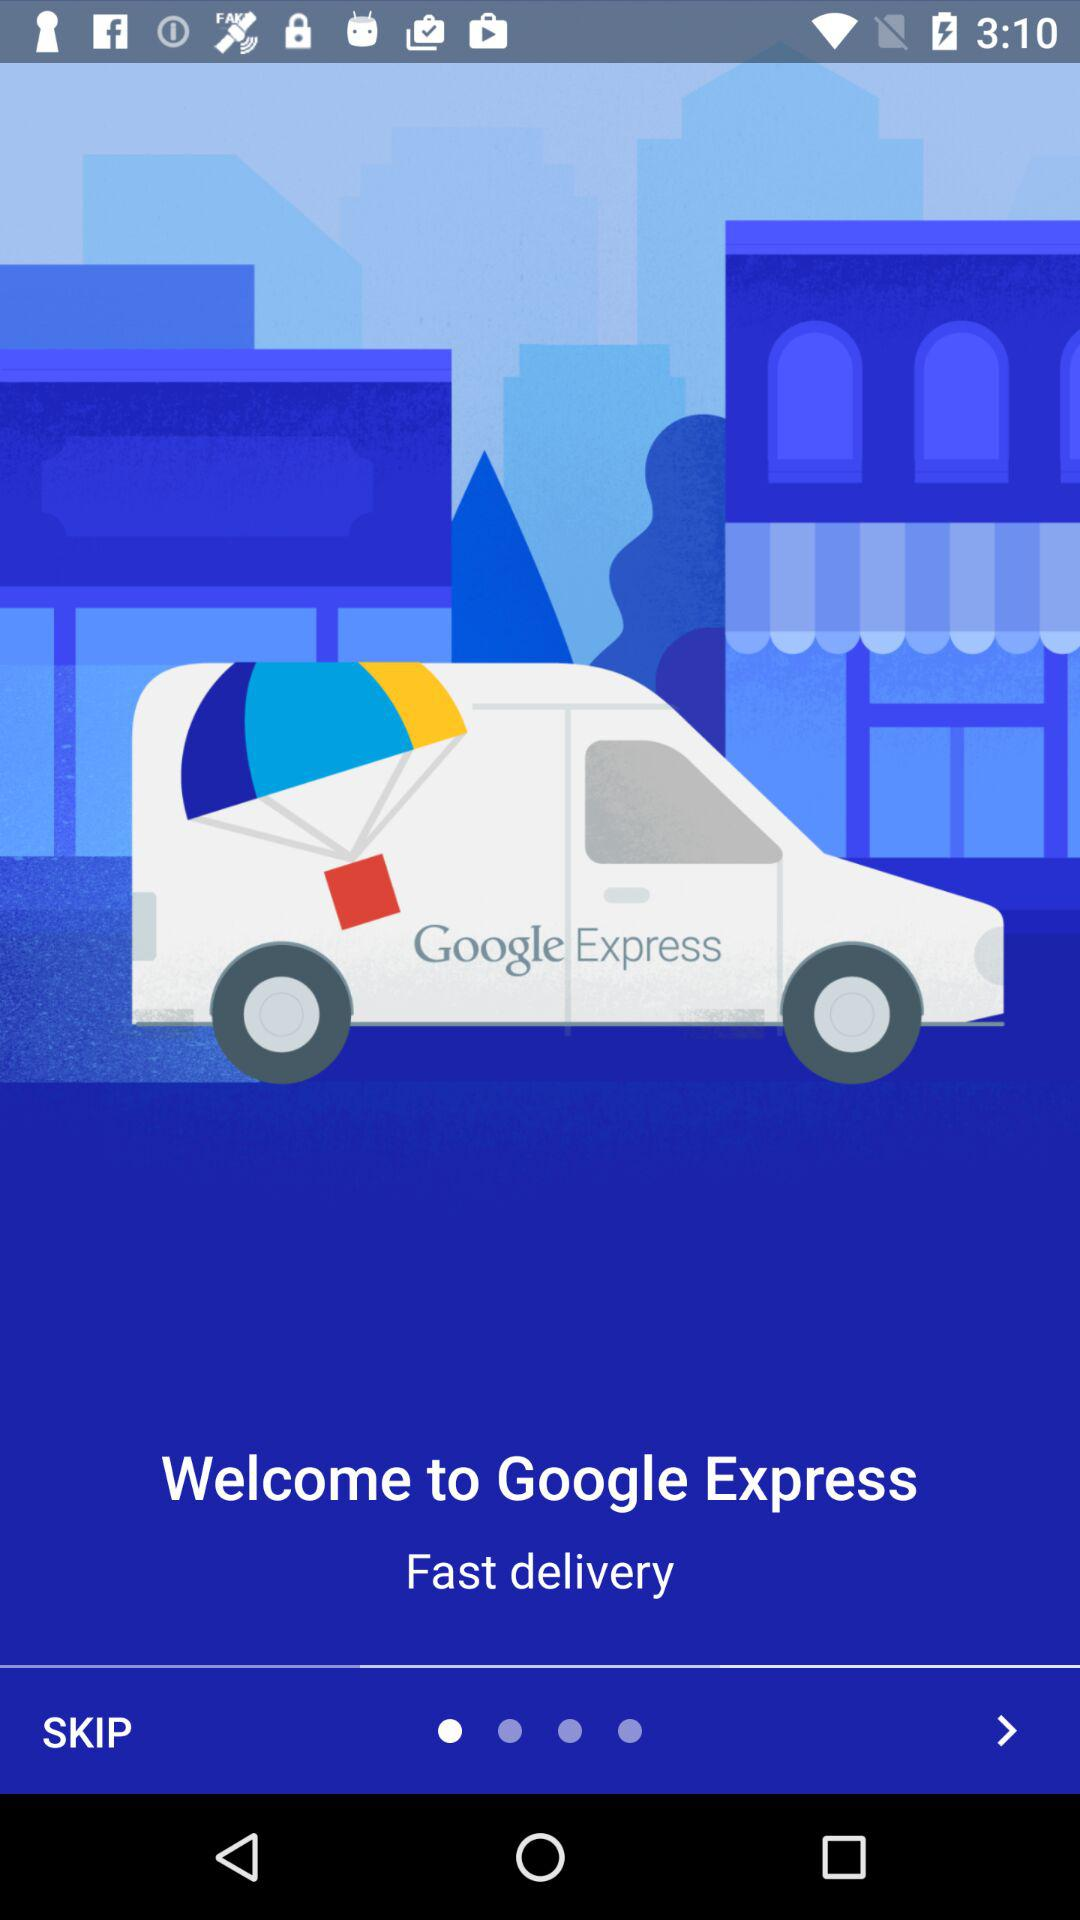What is the name of the application? The name of the application is "Google Express". 